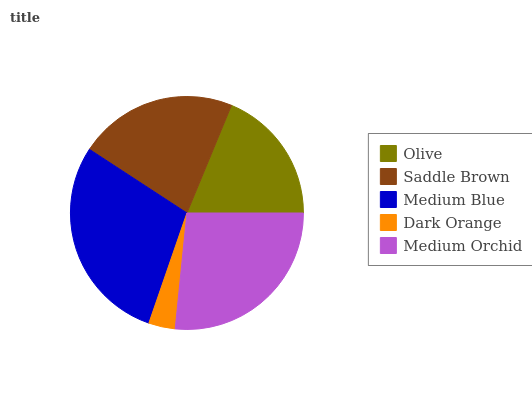Is Dark Orange the minimum?
Answer yes or no. Yes. Is Medium Blue the maximum?
Answer yes or no. Yes. Is Saddle Brown the minimum?
Answer yes or no. No. Is Saddle Brown the maximum?
Answer yes or no. No. Is Saddle Brown greater than Olive?
Answer yes or no. Yes. Is Olive less than Saddle Brown?
Answer yes or no. Yes. Is Olive greater than Saddle Brown?
Answer yes or no. No. Is Saddle Brown less than Olive?
Answer yes or no. No. Is Saddle Brown the high median?
Answer yes or no. Yes. Is Saddle Brown the low median?
Answer yes or no. Yes. Is Medium Orchid the high median?
Answer yes or no. No. Is Olive the low median?
Answer yes or no. No. 